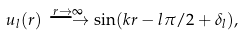<formula> <loc_0><loc_0><loc_500><loc_500>u _ { l } ( r ) \stackrel { r \rightarrow \infty } { \longrightarrow } \sin ( k r - l \pi / 2 + \delta _ { l } ) ,</formula> 